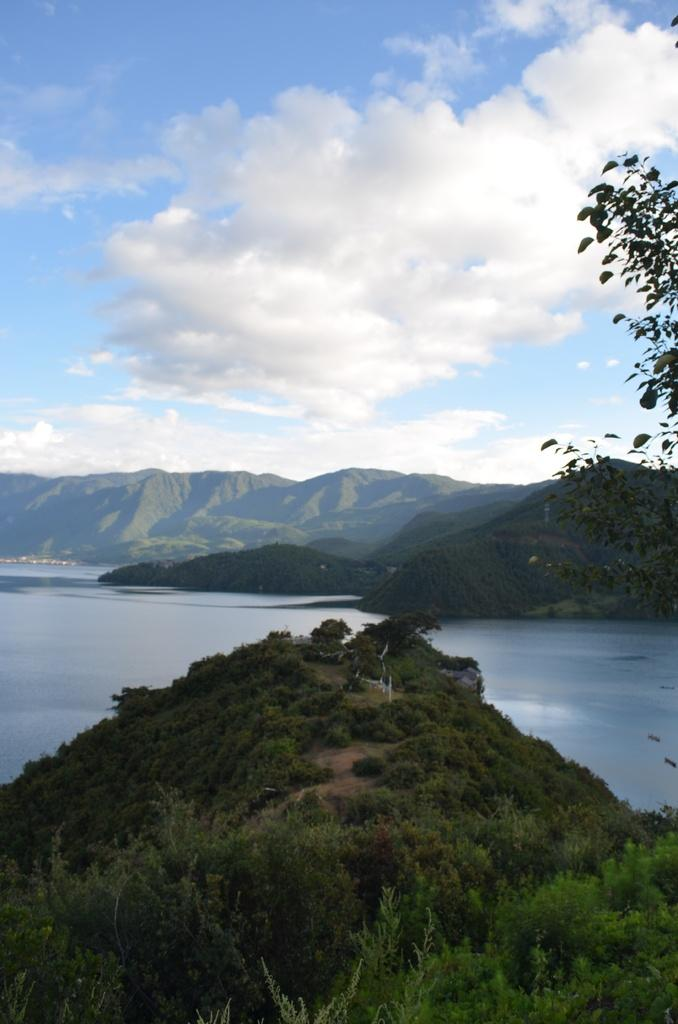What type of vegetation is present in the image? There are trees in the image. What is located in front of the trees? There is water in front of the trees. What can be seen in the background of the image? There are mountains in the background of the image. How would you describe the sky in the image? The sky is visible in the image and appears to be cloudy. How many friends are visible in the image? There are no friends present in the image; it features trees, water, mountains, and a cloudy sky. What shape is the tax in the image? There is no tax present in the image, so it is not possible to determine its shape. 